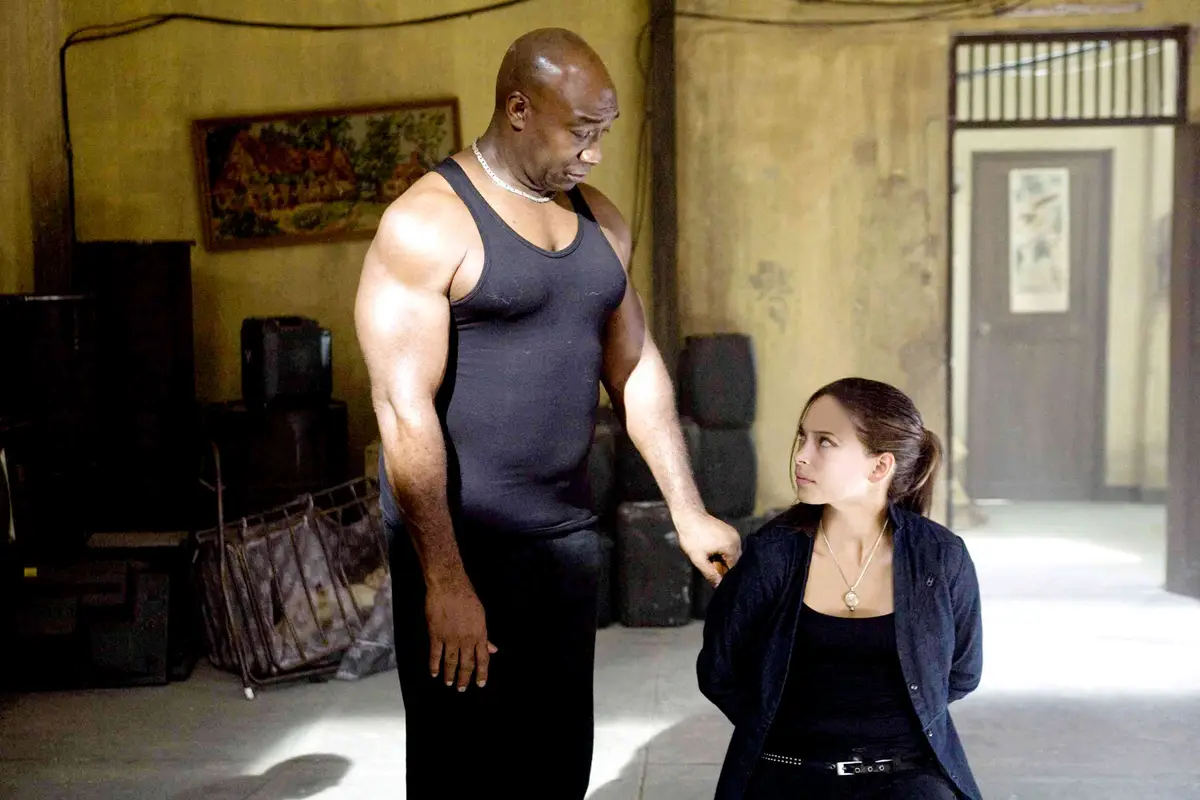Analyze the image in a comprehensive and detailed manner. The image captures a poignant moment between two characters inside what appears to be a dilapidated indoor setting. The man on the left, with a pronounced muscular build and dressed in a simple black tank top, stands dominant yet exhibits a look of gentle engagement. The young woman on the right, seated and dressed in a dark jacket, meets his gaze, suggesting a moment of serious exchange or contemplation between them. The setting adds a layer of depth, with its aged walls and sparse furnishing hinting at a place with stories to tell. This scene could symbolize a moment of mentorship or protection, highlighting the contrasts in their physical appearances and possibly their life experiences. 